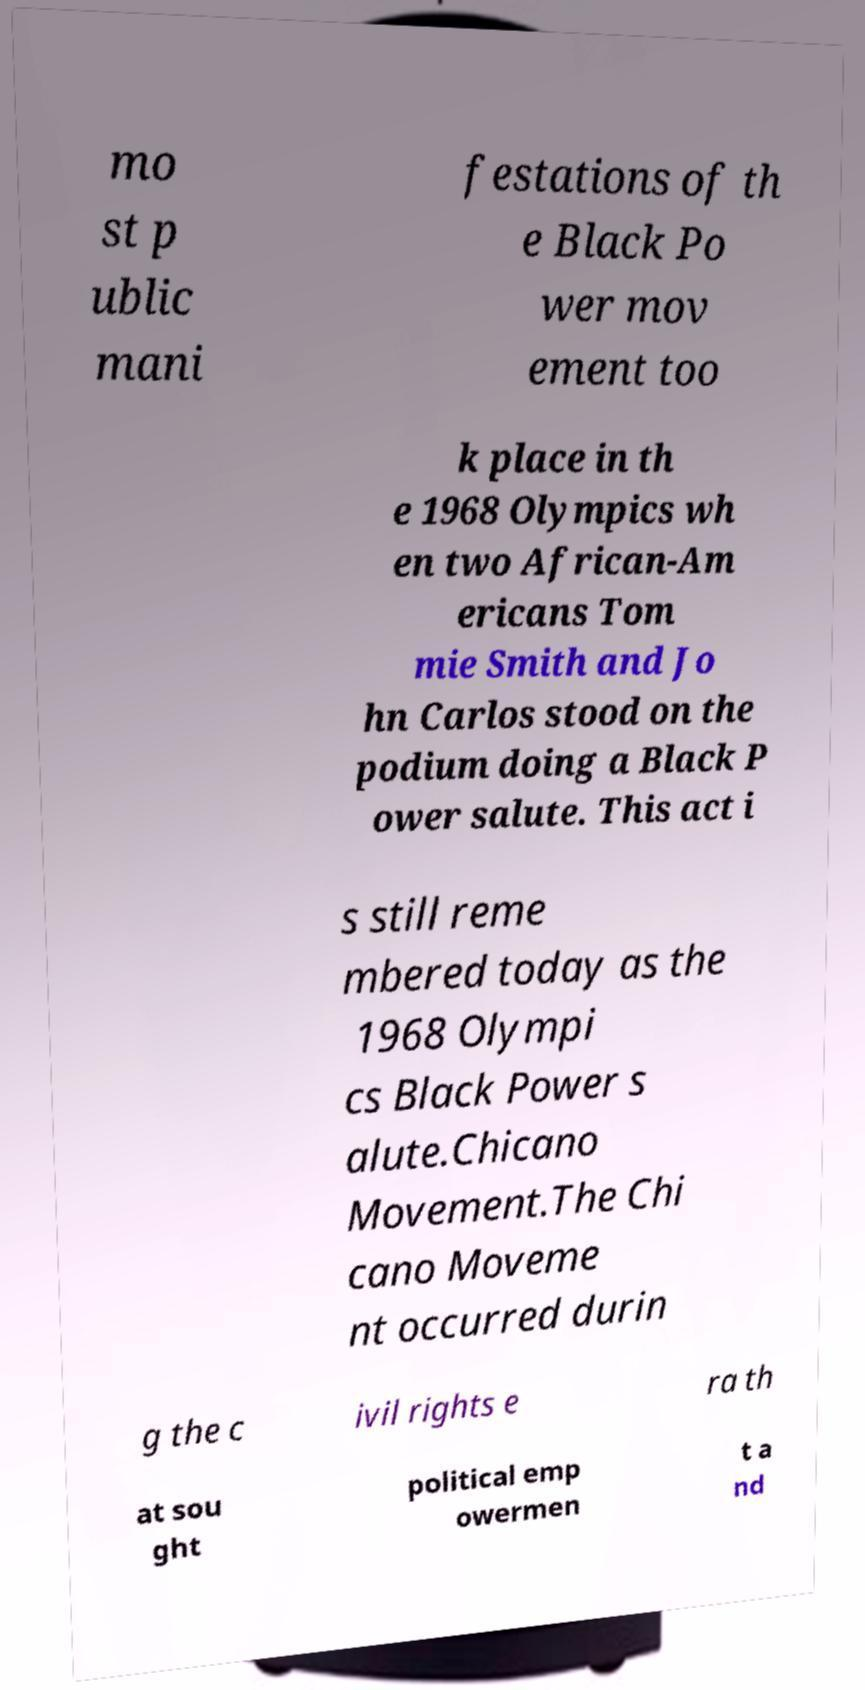There's text embedded in this image that I need extracted. Can you transcribe it verbatim? mo st p ublic mani festations of th e Black Po wer mov ement too k place in th e 1968 Olympics wh en two African-Am ericans Tom mie Smith and Jo hn Carlos stood on the podium doing a Black P ower salute. This act i s still reme mbered today as the 1968 Olympi cs Black Power s alute.Chicano Movement.The Chi cano Moveme nt occurred durin g the c ivil rights e ra th at sou ght political emp owermen t a nd 